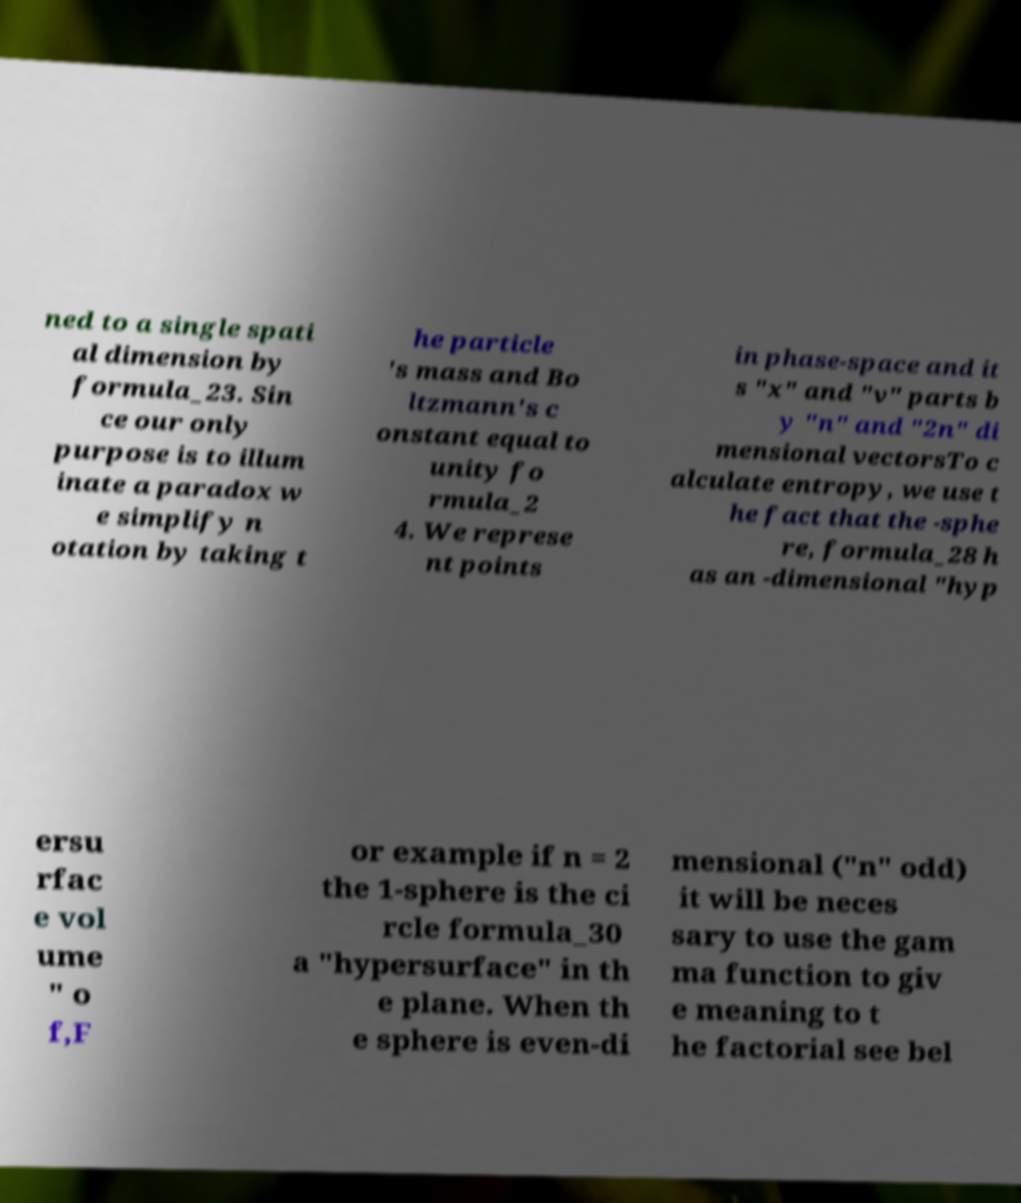I need the written content from this picture converted into text. Can you do that? ned to a single spati al dimension by formula_23. Sin ce our only purpose is to illum inate a paradox w e simplify n otation by taking t he particle 's mass and Bo ltzmann's c onstant equal to unity fo rmula_2 4. We represe nt points in phase-space and it s "x" and "v" parts b y "n" and "2n" di mensional vectorsTo c alculate entropy, we use t he fact that the -sphe re, formula_28 h as an -dimensional "hyp ersu rfac e vol ume " o f,F or example if n = 2 the 1-sphere is the ci rcle formula_30 a "hypersurface" in th e plane. When th e sphere is even-di mensional ("n" odd) it will be neces sary to use the gam ma function to giv e meaning to t he factorial see bel 